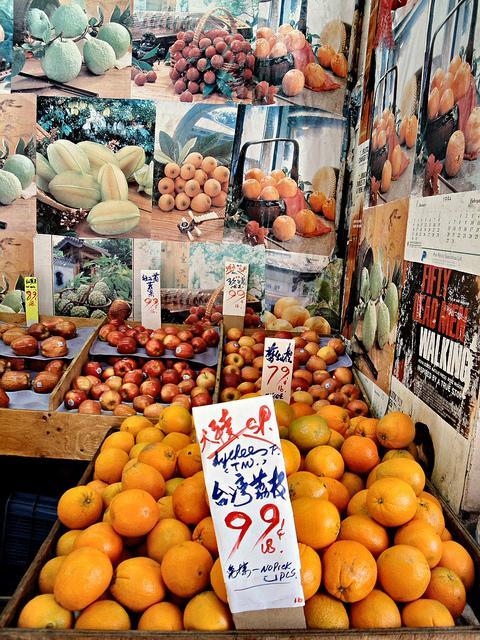How much would 2 pounds of oranges cost?

Choices:
A) 1.92
B) 1.63
C) 1.98
D) 1.49 1.98 